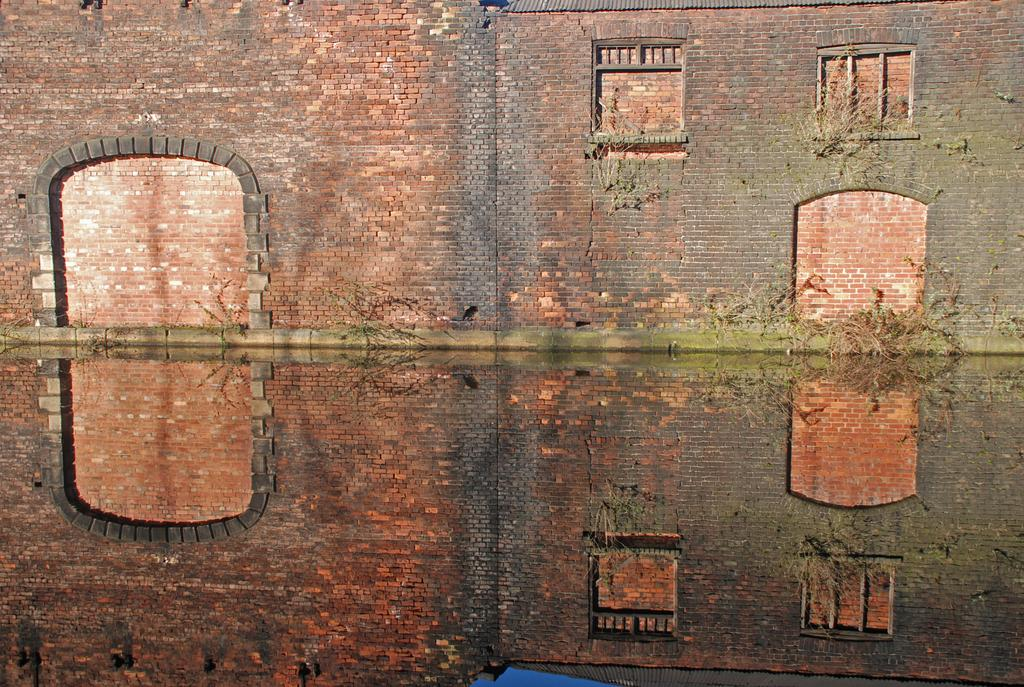What is the main subject of the image? The main subject of the image is a building wall. What is the condition of the windows on the wall? The windows on the building wall are closed with bricks. What type of vegetation is growing on the wall? There are creepers growing on the wall. What type of hat is the person wearing in the image? There is no person present in the image, so there is no hat to be described. 